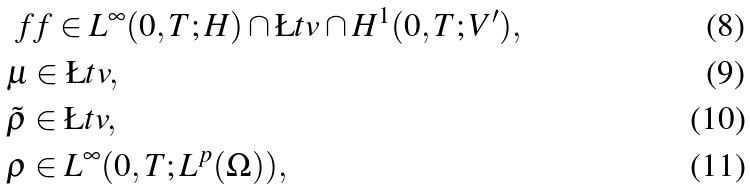Convert formula to latex. <formula><loc_0><loc_0><loc_500><loc_500>& \ f f \in L ^ { \infty } ( 0 , T ; H ) \cap \L t v \cap H ^ { 1 } ( 0 , T ; V ^ { \prime } ) , \\ & \mu \in \L t v , \\ & \tilde { \rho } \in \L t v , \\ & \rho \in L ^ { \infty } ( 0 , T ; L ^ { p } ( \Omega ) ) ,</formula> 